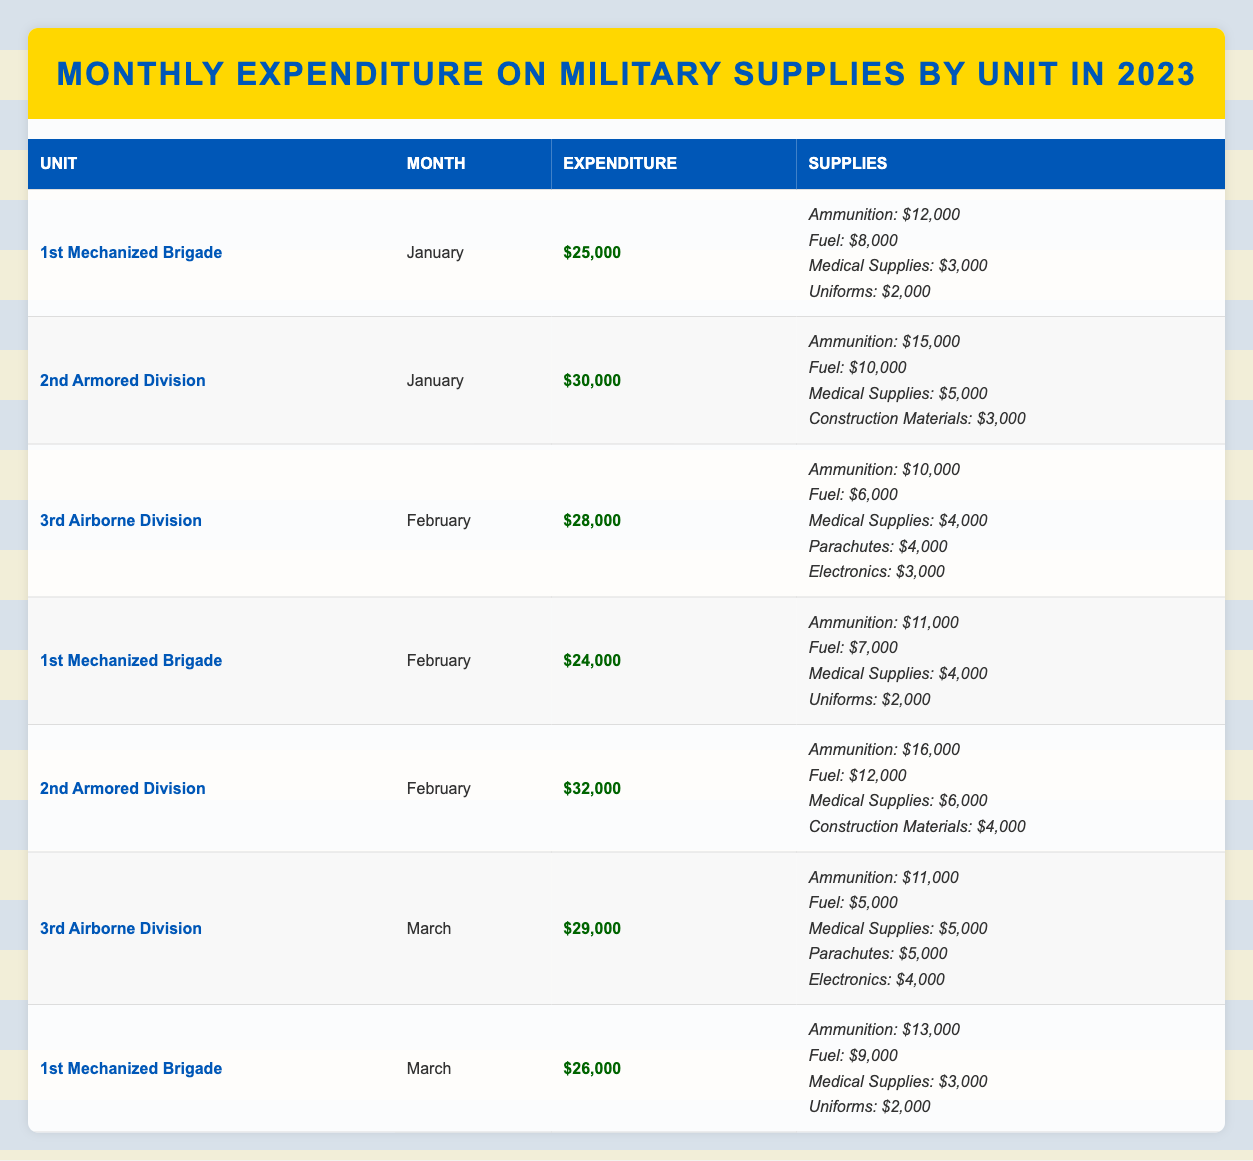What was the total expenditure of the 1st Mechanized Brigade in January 2023? The table shows that the expenditure for the 1st Mechanized Brigade in January is $25,000.
Answer: $25,000 Which unit had the highest expenditure in February 2023? In February, the expenditures were $28,000 for the 3rd Airborne Division, $24,000 for the 1st Mechanized Brigade, and $32,000 for the 2nd Armored Division. The highest is $32,000 for the 2nd Armored Division.
Answer: 2nd Armored Division What is the total expenditure for the 3rd Airborne Division across all reported months? The expenditures for the 3rd Airborne Division are $28,000 in February and $29,000 in March. Adding these two values: $28,000 + $29,000 = $57,000.
Answer: $57,000 Did any unit spend more than $30,000 in January 2023? The expenditures for January are $25,000 for the 1st Mechanized Brigade and $30,000 for the 2nd Armored Division. The value $30,000 meets the criterion, so yes, the 2nd Armored Division did.
Answer: Yes What was the difference in ammunition expenditure between the 1st Mechanized Brigade and the 2nd Armored Division in January 2023? The 1st Mechanized Brigade spent $12,000 on ammunition, while the 2nd Armored Division spent $15,000. The difference is $15,000 - $12,000 = $3,000.
Answer: $3,000 What is the average expenditure per month for the 2nd Armored Division? The expenditures for the 2nd Armored Division are $30,000 in January and $32,000 in February. Summing these gives $30,000 + $32,000 = $62,000. Dividing by 2 months gives $62,000 / 2 = $31,000.
Answer: $31,000 Which unit had the lowest total expenditure across all months recorded? Adding up expenditures for each unit: 1st Mechanized Brigade: $25,000 + $24,000 + $26,000 = $75,000; 2nd Armored Division: $30,000 + $32,000 = $62,000; 3rd Airborne Division: $28,000 + $29,000 = $57,000. The 3rd Airborne Division's total of $57,000 is the lowest.
Answer: 3rd Airborne Division Is it true that the 1st Mechanized Brigade had higher medical supplies expenditure in March than in February? In March, the medical supplies expenditure was $3,000 and in February it was $4,000, so $3,000 < $4,000 is false.
Answer: No What percentage of the total expenditure for January 2023 was spent on medical supplies by the 2nd Armored Division? The 2nd Armored Division had a total expenditure of $30,000 in January, with $5,000 spent on medical supplies. The percentage is ($5,000 / $30,000) * 100 = 16.67%.
Answer: 16.67% 